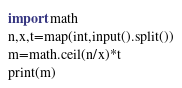<code> <loc_0><loc_0><loc_500><loc_500><_Python_>import math
n,x,t=map(int,input().split())
m=math.ceil(n/x)*t
print(m)</code> 